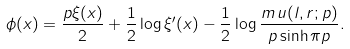Convert formula to latex. <formula><loc_0><loc_0><loc_500><loc_500>\phi ( x ) = \frac { p \xi ( x ) } { 2 } + \frac { 1 } { 2 } \log \xi ^ { \prime } ( x ) - \frac { 1 } { 2 } \log \frac { m \, u ( l , r ; p ) } { p \sinh \pi p } .</formula> 